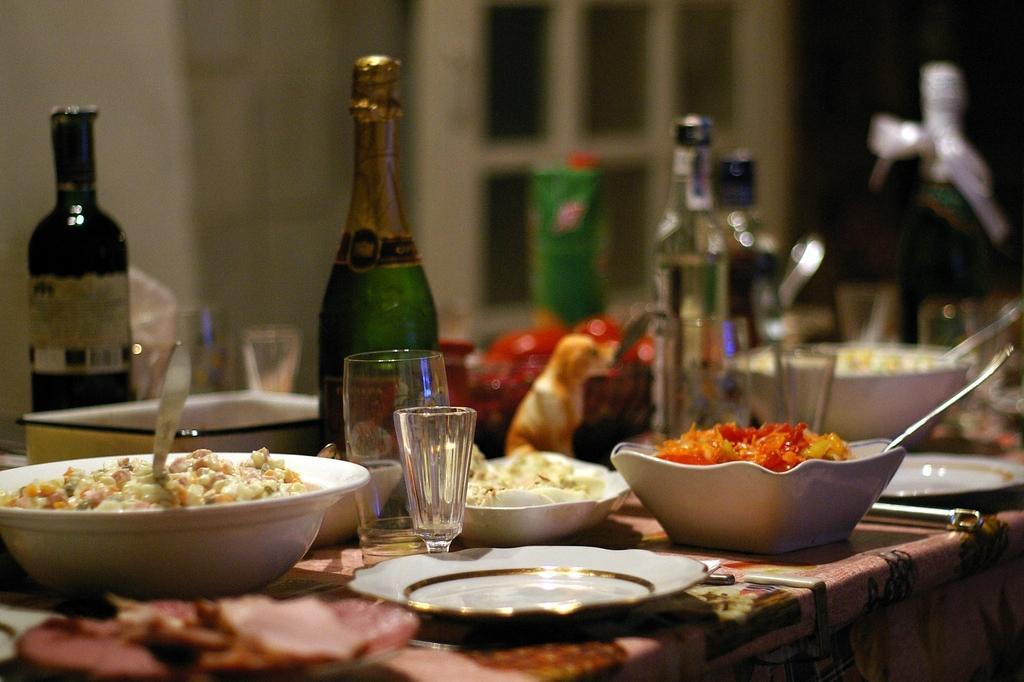In one or two sentences, can you explain what this image depicts? This is a picture taken in a room, this is a table on the table there is a bowl, spoon, glass, bottle and a box. Background of this table is a wall. 